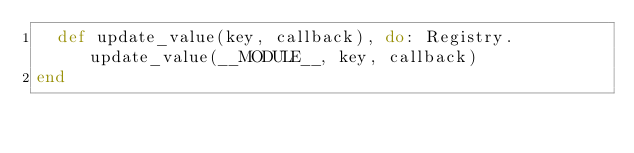<code> <loc_0><loc_0><loc_500><loc_500><_Elixir_>  def update_value(key, callback), do: Registry.update_value(__MODULE__, key, callback)
end
</code> 